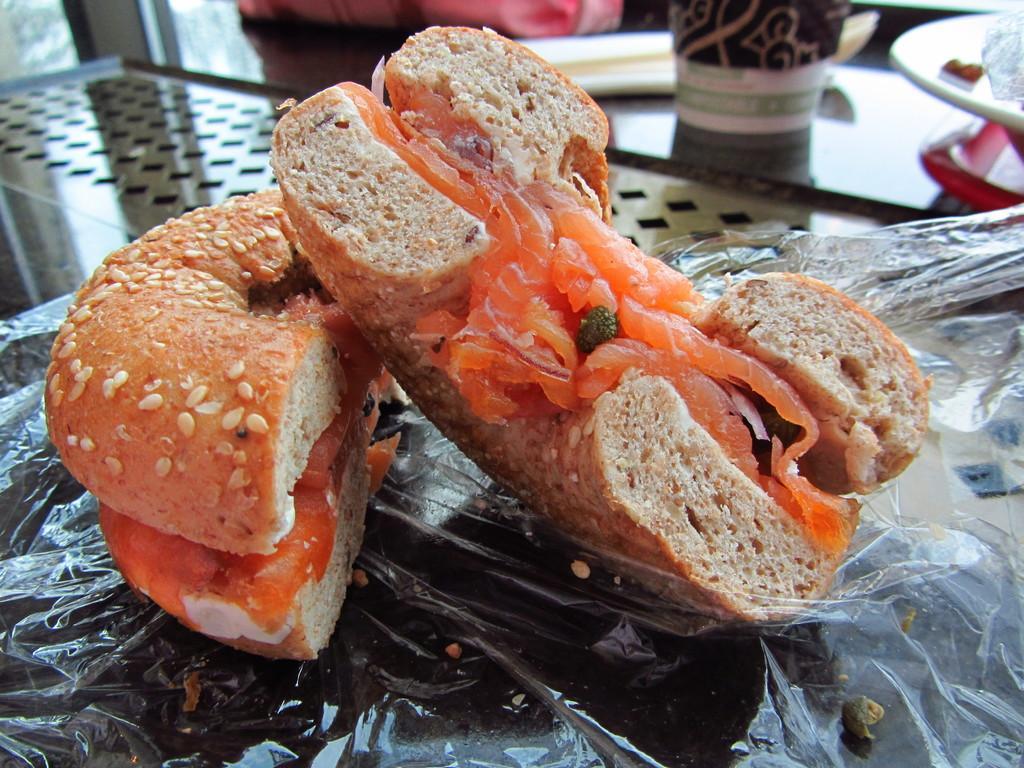In one or two sentences, can you explain what this image depicts? In the image in the center, we can see one table. On the table, there is a bag, glass, plate, plastic cover, some food items and a few other objects. 